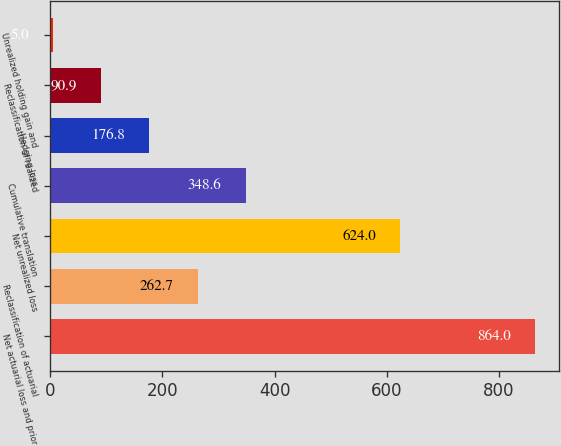Convert chart. <chart><loc_0><loc_0><loc_500><loc_500><bar_chart><fcel>Net actuarial loss and prior<fcel>Reclassification of actuarial<fcel>Net unrealized loss<fcel>Cumulative translation<fcel>Hedging loss<fcel>Reclassification of realized<fcel>Unrealized holding gain and<nl><fcel>864<fcel>262.7<fcel>624<fcel>348.6<fcel>176.8<fcel>90.9<fcel>5<nl></chart> 